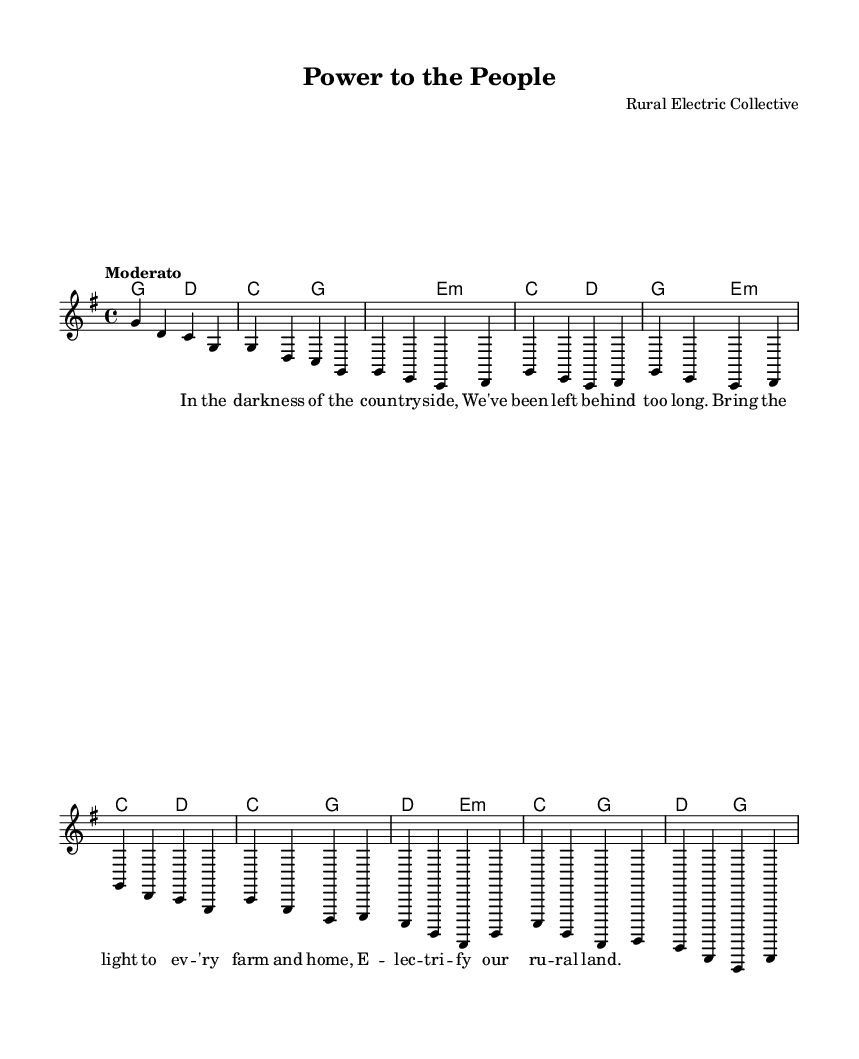What is the key signature of this music? The key signature is G major, which has one sharp (F#). This can be identified just before the first note of the staff.
Answer: G major What is the time signature of the piece? The time signature shown in the music is 4/4, which indicates four beats per measure and the quarter note gets one beat. This can be seen at the beginning of the score.
Answer: 4/4 What is the tempo marking for this song? The tempo marking indicated in the music is "Moderato," which suggests a moderate speed. This is located at the beginning of the score, right after the time signature.
Answer: Moderato How many measures are in the intro section? The intro section consists of two measures, as it is represented visually by the two sequences of notes (g4 d c g and g d c g). Each sequence is one measure long.
Answer: 2 What is the relation of the first verse to the chorus in terms of structure? The first verse is partial and precedes the chorus, which is also partial. This structure is typical in folk songs, allowing for repetition and emphasis on the main theme, as seen in the layout of the song.
Answer: Verse precedes chorus How many chords are used in the chorus? The chorus section contains four distinct chords (C, G, D, E minor) as indicated by the chord names above the melody. Each chord in the chord mode further reiterates these changes across the measures of the chorus.
Answer: 4 What is the overall theme of the lyrics in relation to rural electrification? The lyrics emphasize bringing electricity to rural areas, thus highlighting social progress and the need for development in the countryside, which embodies the essence of protest folk songs. This theme is articulated in both the verses and the chorus.
Answer: Rural electrification 